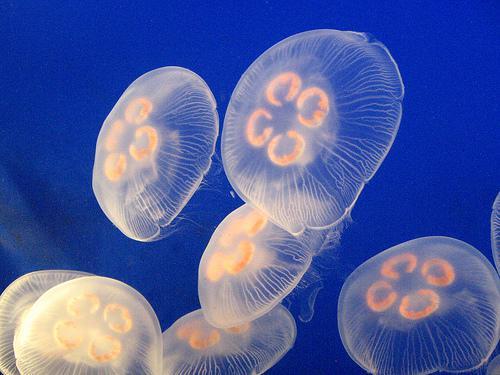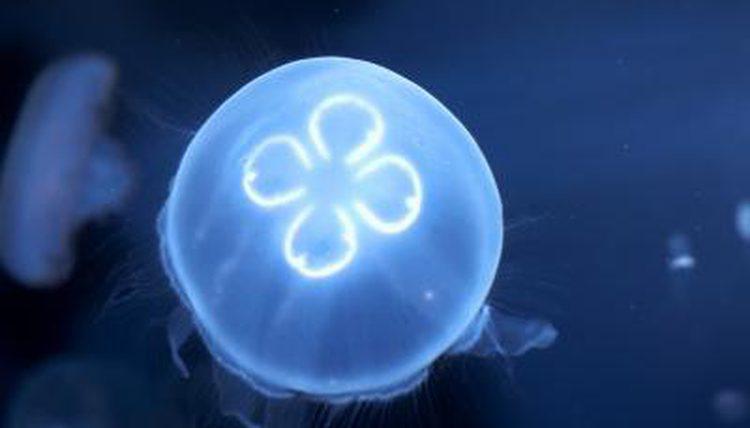The first image is the image on the left, the second image is the image on the right. Examine the images to the left and right. Is the description "One of the images shows a tortoise interacting with a jellyfish." accurate? Answer yes or no. No. The first image is the image on the left, the second image is the image on the right. For the images shown, is this caption "The left image contains one round jellyfish with glowing white color, and the right image features a sea turtle next to a round shape." true? Answer yes or no. No. 